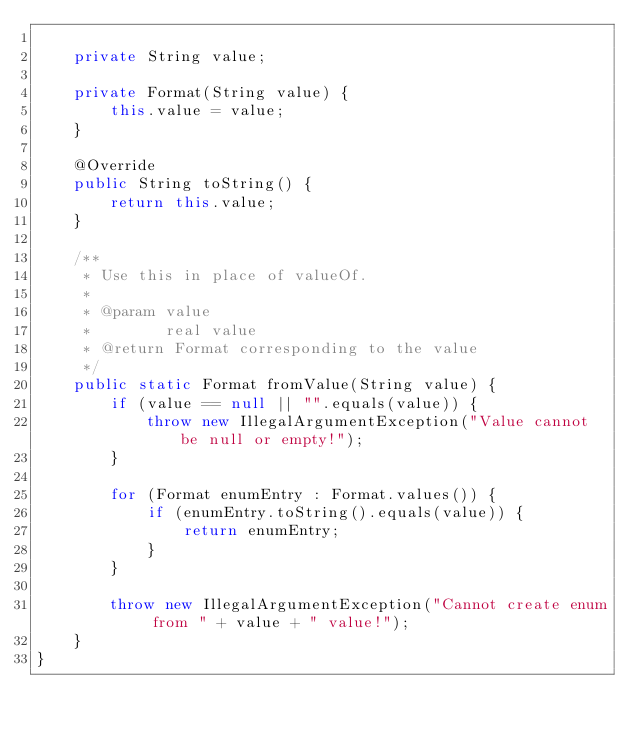<code> <loc_0><loc_0><loc_500><loc_500><_Java_>
    private String value;

    private Format(String value) {
        this.value = value;
    }

    @Override
    public String toString() {
        return this.value;
    }

    /**
     * Use this in place of valueOf.
     *
     * @param value
     *        real value
     * @return Format corresponding to the value
     */
    public static Format fromValue(String value) {
        if (value == null || "".equals(value)) {
            throw new IllegalArgumentException("Value cannot be null or empty!");
        }

        for (Format enumEntry : Format.values()) {
            if (enumEntry.toString().equals(value)) {
                return enumEntry;
            }
        }

        throw new IllegalArgumentException("Cannot create enum from " + value + " value!");
    }
}
</code> 